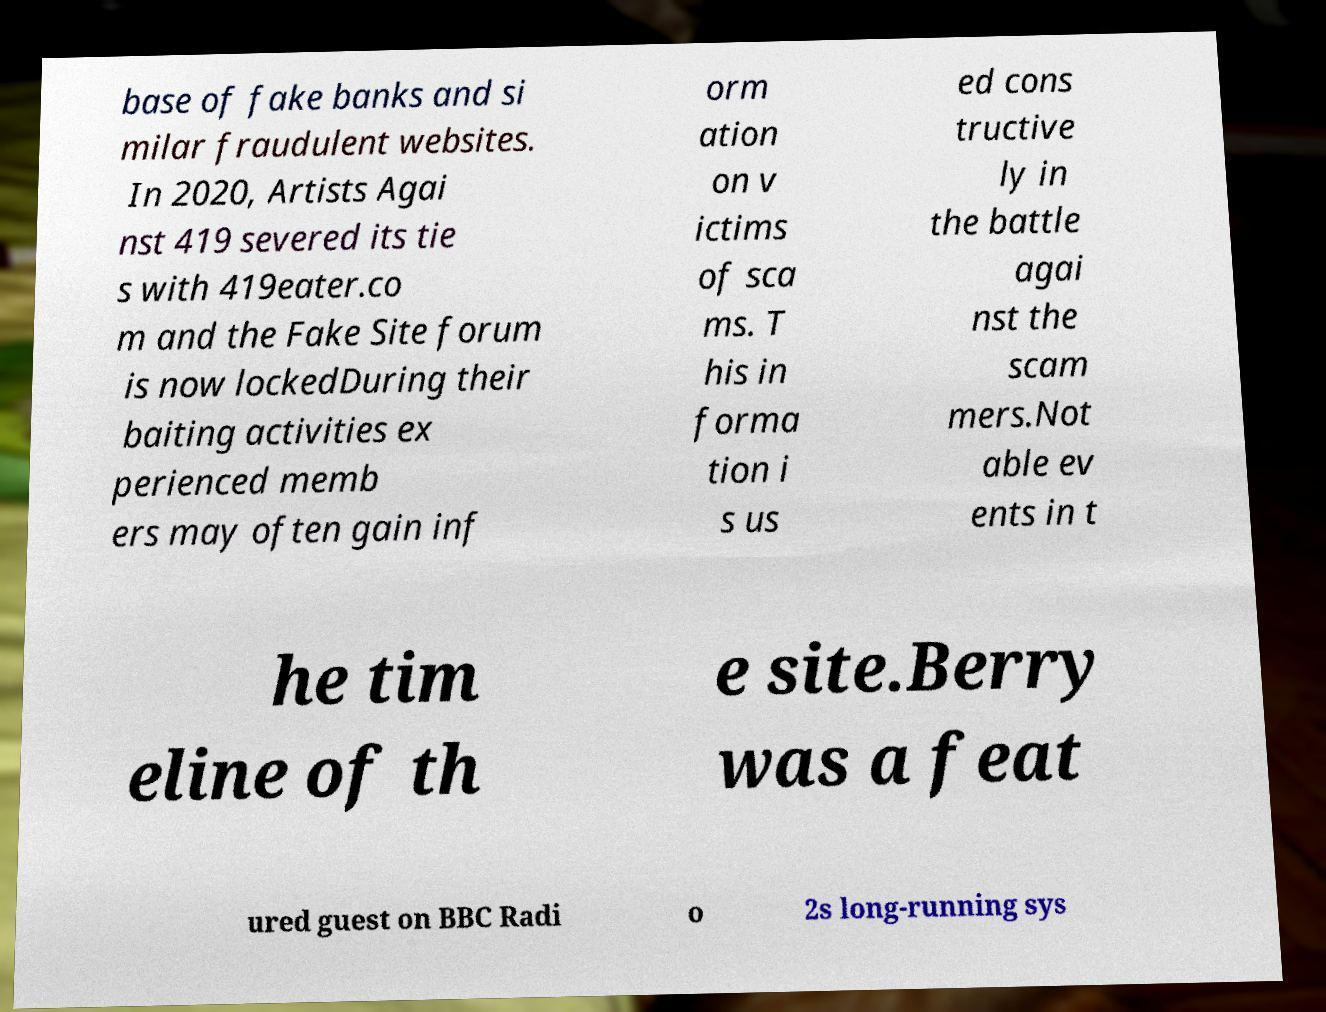What messages or text are displayed in this image? I need them in a readable, typed format. base of fake banks and si milar fraudulent websites. In 2020, Artists Agai nst 419 severed its tie s with 419eater.co m and the Fake Site forum is now lockedDuring their baiting activities ex perienced memb ers may often gain inf orm ation on v ictims of sca ms. T his in forma tion i s us ed cons tructive ly in the battle agai nst the scam mers.Not able ev ents in t he tim eline of th e site.Berry was a feat ured guest on BBC Radi o 2s long-running sys 